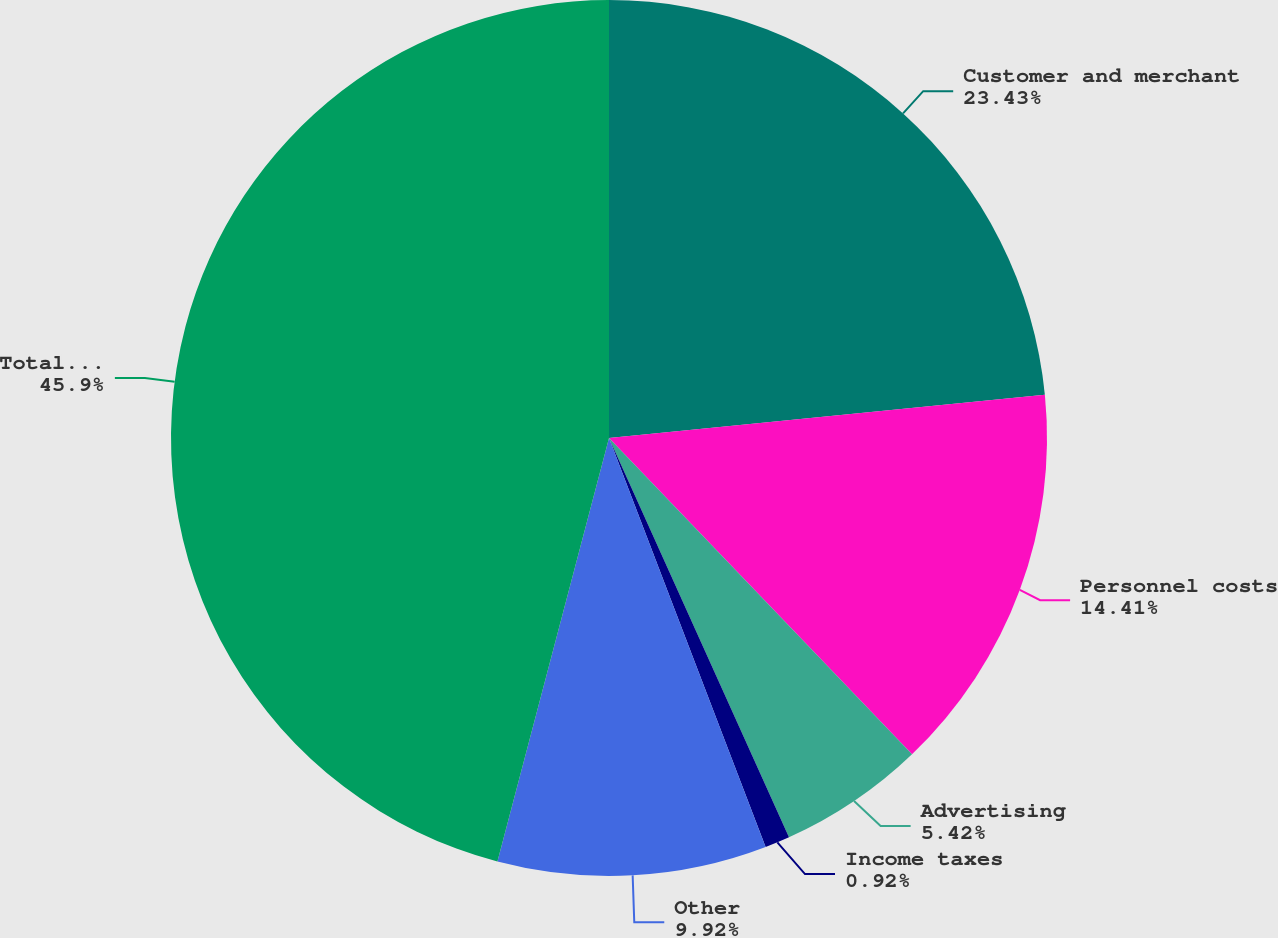Convert chart to OTSL. <chart><loc_0><loc_0><loc_500><loc_500><pie_chart><fcel>Customer and merchant<fcel>Personnel costs<fcel>Advertising<fcel>Income taxes<fcel>Other<fcel>Total accrued expenses<nl><fcel>23.43%<fcel>14.41%<fcel>5.42%<fcel>0.92%<fcel>9.92%<fcel>45.9%<nl></chart> 